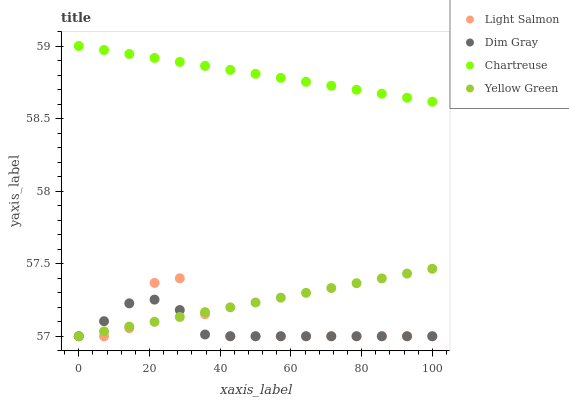Does Dim Gray have the minimum area under the curve?
Answer yes or no. Yes. Does Chartreuse have the maximum area under the curve?
Answer yes or no. Yes. Does Chartreuse have the minimum area under the curve?
Answer yes or no. No. Does Dim Gray have the maximum area under the curve?
Answer yes or no. No. Is Chartreuse the smoothest?
Answer yes or no. Yes. Is Light Salmon the roughest?
Answer yes or no. Yes. Is Dim Gray the smoothest?
Answer yes or no. No. Is Dim Gray the roughest?
Answer yes or no. No. Does Light Salmon have the lowest value?
Answer yes or no. Yes. Does Chartreuse have the lowest value?
Answer yes or no. No. Does Chartreuse have the highest value?
Answer yes or no. Yes. Does Dim Gray have the highest value?
Answer yes or no. No. Is Dim Gray less than Chartreuse?
Answer yes or no. Yes. Is Chartreuse greater than Yellow Green?
Answer yes or no. Yes. Does Dim Gray intersect Yellow Green?
Answer yes or no. Yes. Is Dim Gray less than Yellow Green?
Answer yes or no. No. Is Dim Gray greater than Yellow Green?
Answer yes or no. No. Does Dim Gray intersect Chartreuse?
Answer yes or no. No. 